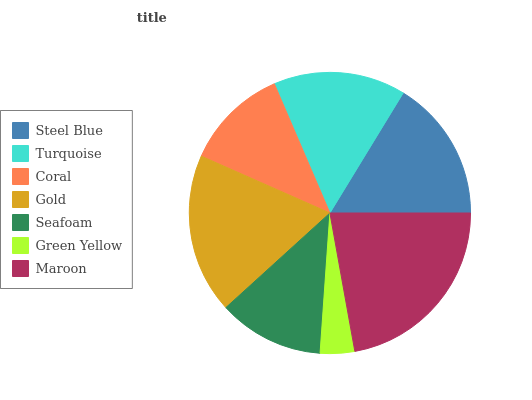Is Green Yellow the minimum?
Answer yes or no. Yes. Is Maroon the maximum?
Answer yes or no. Yes. Is Turquoise the minimum?
Answer yes or no. No. Is Turquoise the maximum?
Answer yes or no. No. Is Steel Blue greater than Turquoise?
Answer yes or no. Yes. Is Turquoise less than Steel Blue?
Answer yes or no. Yes. Is Turquoise greater than Steel Blue?
Answer yes or no. No. Is Steel Blue less than Turquoise?
Answer yes or no. No. Is Turquoise the high median?
Answer yes or no. Yes. Is Turquoise the low median?
Answer yes or no. Yes. Is Green Yellow the high median?
Answer yes or no. No. Is Coral the low median?
Answer yes or no. No. 